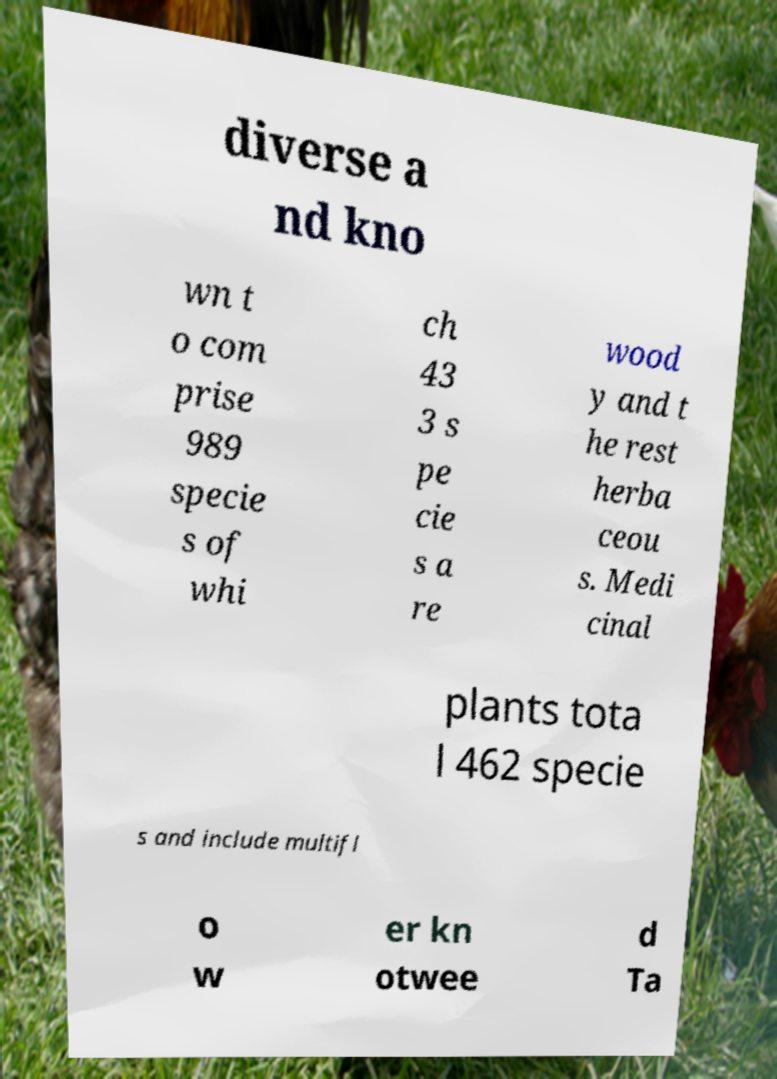What messages or text are displayed in this image? I need them in a readable, typed format. diverse a nd kno wn t o com prise 989 specie s of whi ch 43 3 s pe cie s a re wood y and t he rest herba ceou s. Medi cinal plants tota l 462 specie s and include multifl o w er kn otwee d Ta 